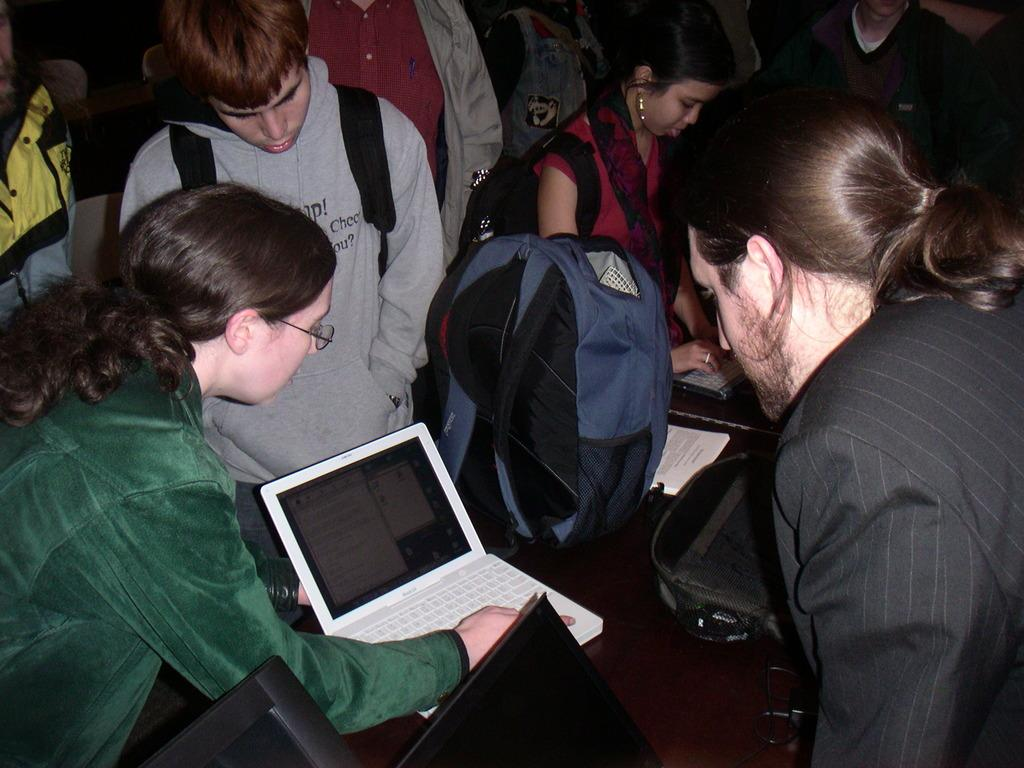Who or what is present in the image? There are people in the image. What electronic device can be seen in the image? There is a laptop in the image. What type of accessory is visible in the image? There is a bag in the image. What type of steel is used to construct the territory in the image? There is no territory or steel present in the image. 